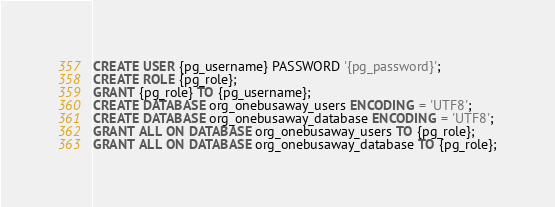<code> <loc_0><loc_0><loc_500><loc_500><_SQL_>CREATE USER {pg_username} PASSWORD '{pg_password}';
CREATE ROLE {pg_role};
GRANT {pg_role} TO {pg_username};
CREATE DATABASE org_onebusaway_users ENCODING = 'UTF8'; 
CREATE DATABASE org_onebusaway_database ENCODING = 'UTF8';
GRANT ALL ON DATABASE org_onebusaway_users TO {pg_role};
GRANT ALL ON DATABASE org_onebusaway_database TO {pg_role};</code> 